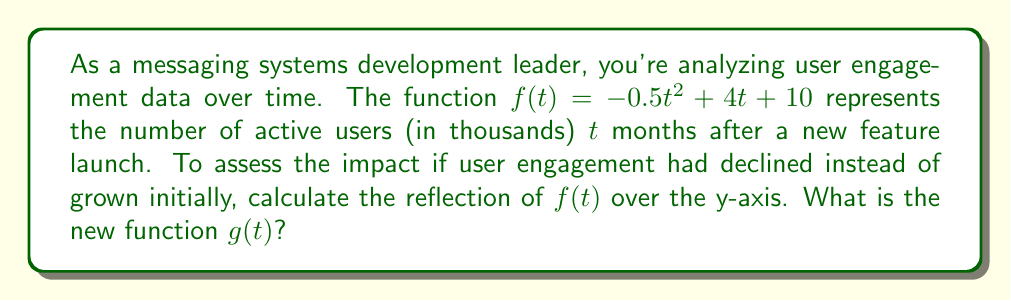Provide a solution to this math problem. To reflect a function over the y-axis, we replace every $t$ with $-t$ in the original function. This process involves the following steps:

1. Start with the original function: $f(t) = -0.5t^2 + 4t + 10$

2. Replace each $t$ with $-t$:
   $g(t) = -0.5(-t)^2 + 4(-t) + 10$

3. Simplify the squared term:
   $g(t) = -0.5t^2 - 4t + 10$

   Note that $(-t)^2 = t^2$ because squaring a negative number results in a positive number.

4. The linear term $4(-t)$ simplifies to $-4t$.

5. The constant term remains unchanged.

Therefore, the reflected function $g(t)$ is $-0.5t^2 - 4t + 10$.

This reflection over the y-axis effectively reverses the time axis, showing how user engagement would have looked if the trend had been mirrored from the start. In the context of messaging system development, this could represent a scenario where user engagement declined initially instead of growing, allowing for comparative analysis of different potential outcomes.
Answer: $g(t) = -0.5t^2 - 4t + 10$ 